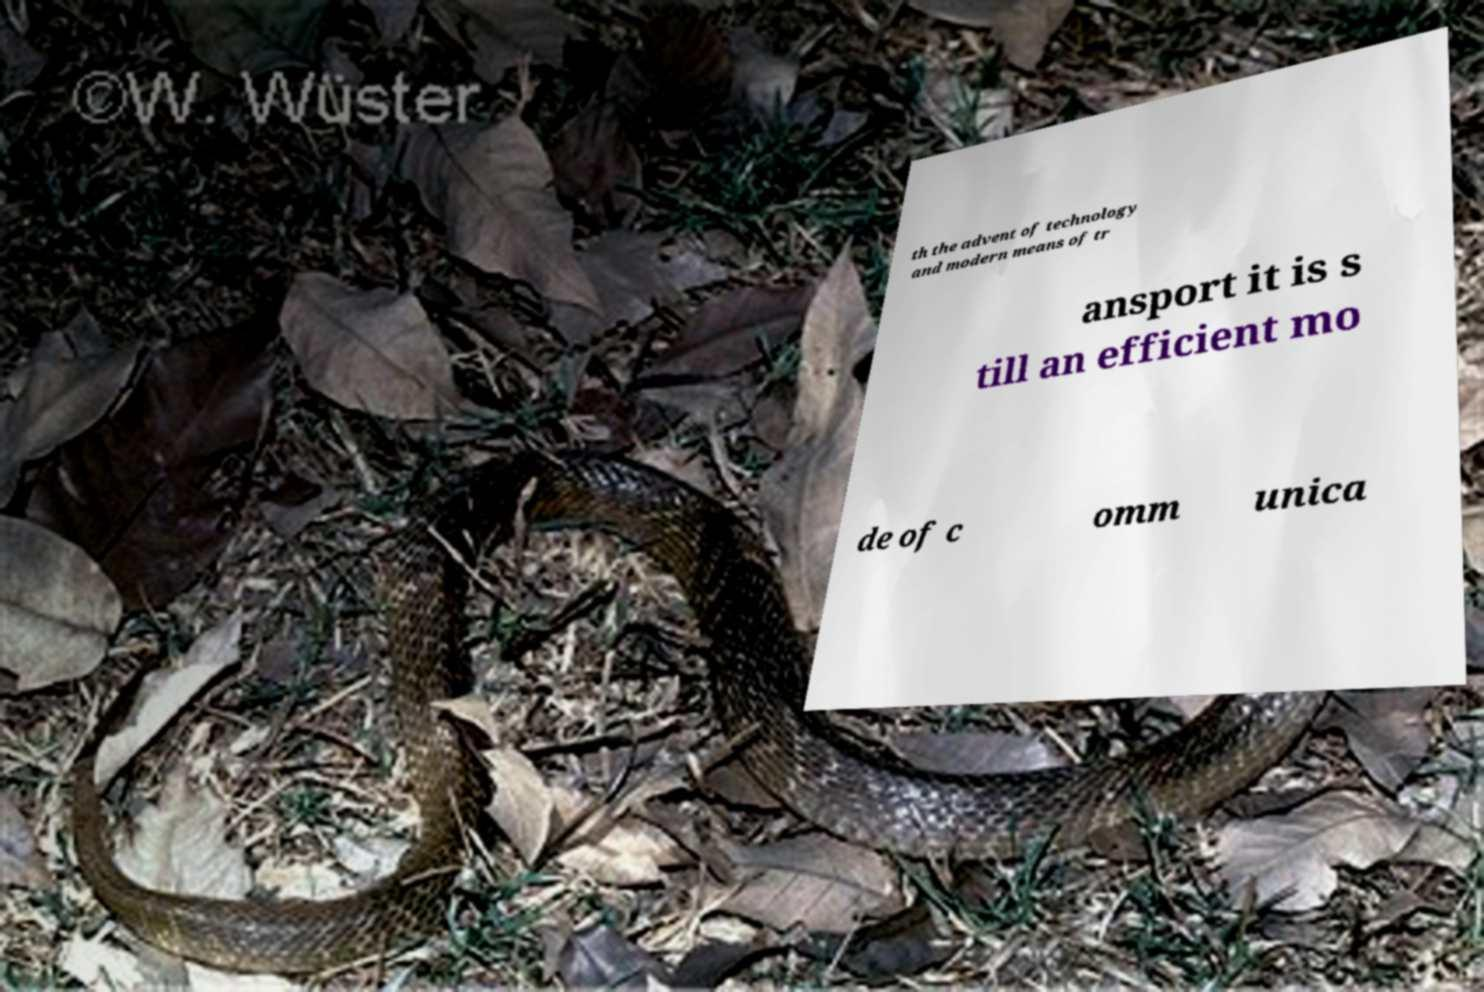Can you read and provide the text displayed in the image?This photo seems to have some interesting text. Can you extract and type it out for me? th the advent of technology and modern means of tr ansport it is s till an efficient mo de of c omm unica 